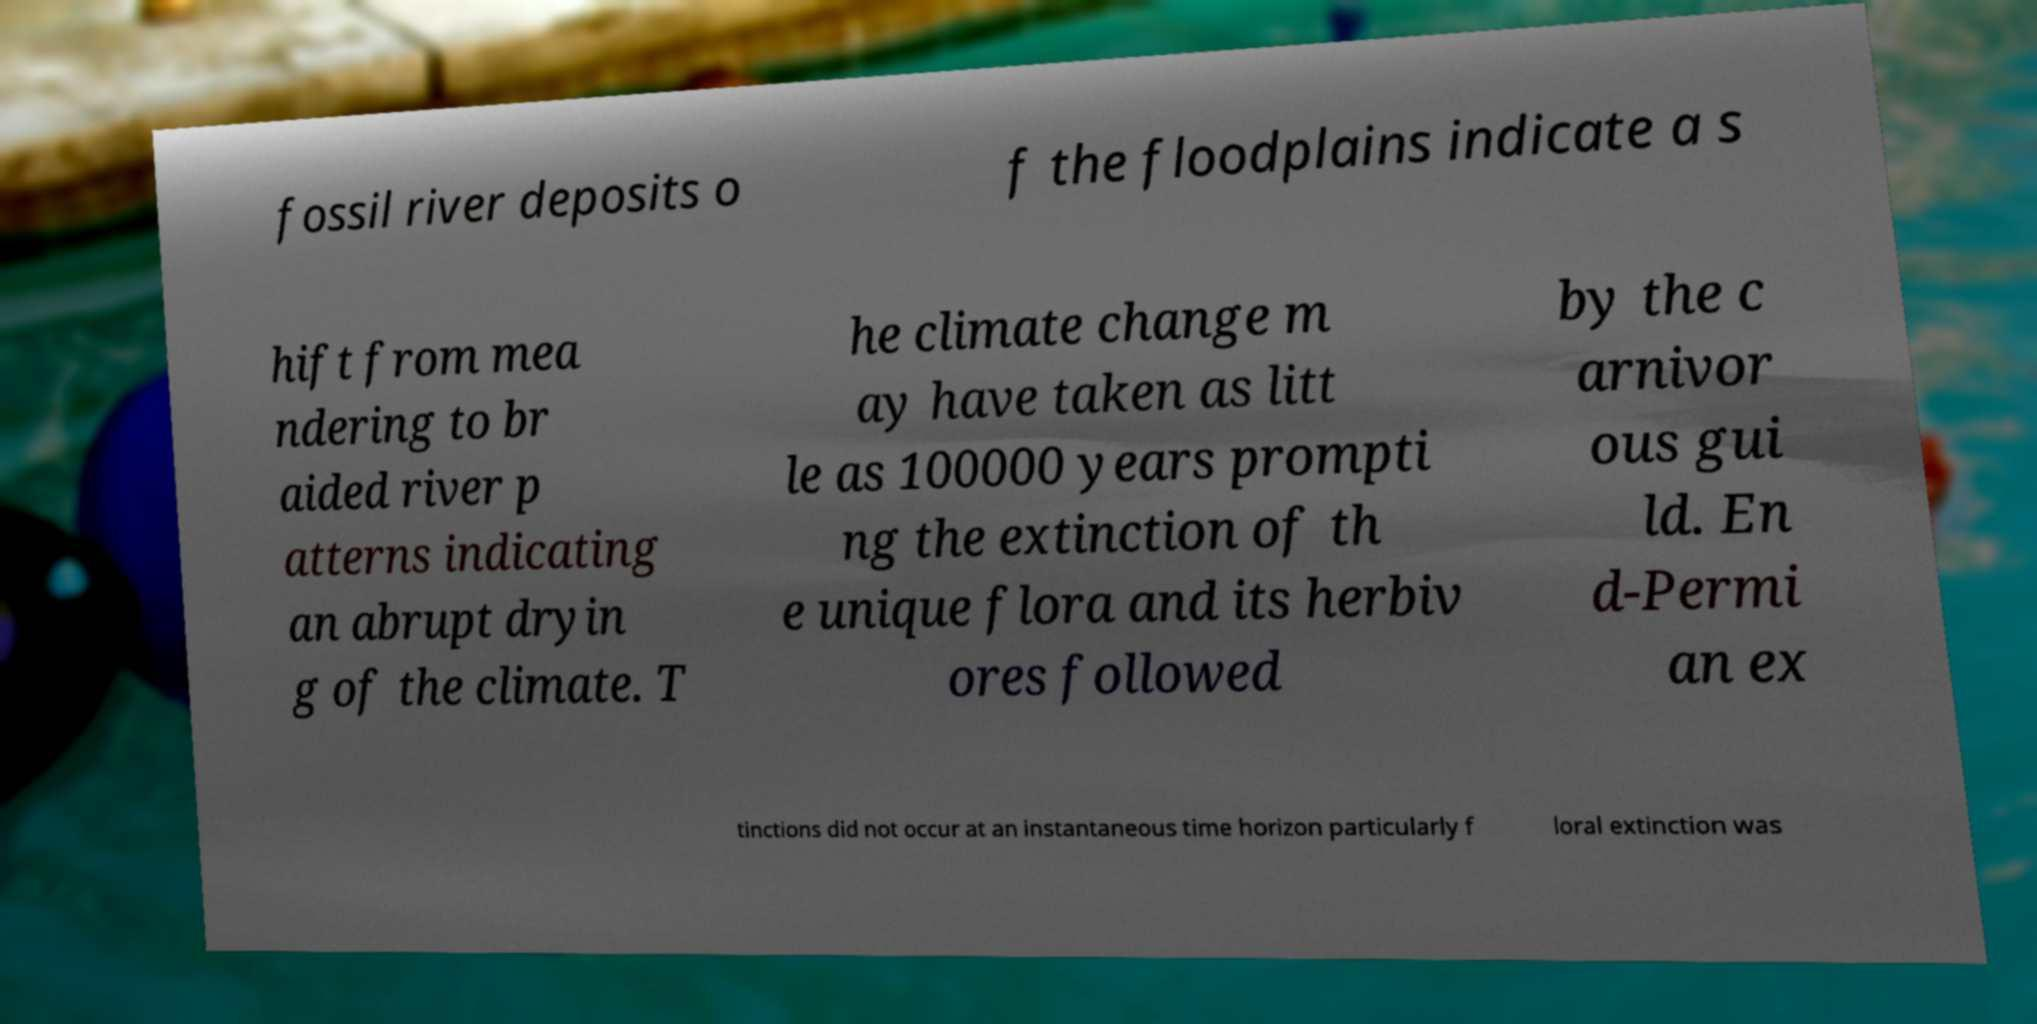What messages or text are displayed in this image? I need them in a readable, typed format. fossil river deposits o f the floodplains indicate a s hift from mea ndering to br aided river p atterns indicating an abrupt dryin g of the climate. T he climate change m ay have taken as litt le as 100000 years prompti ng the extinction of th e unique flora and its herbiv ores followed by the c arnivor ous gui ld. En d-Permi an ex tinctions did not occur at an instantaneous time horizon particularly f loral extinction was 